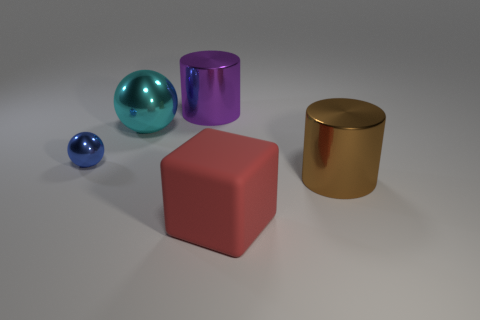Is there a big purple object that is right of the cylinder right of the big red rubber thing?
Your answer should be compact. No. Are there fewer large shiny objects left of the big rubber cube than big brown metallic things?
Keep it short and to the point. No. Is the large thing that is in front of the brown cylinder made of the same material as the brown cylinder?
Your answer should be compact. No. There is a large ball that is the same material as the big brown cylinder; what is its color?
Your response must be concise. Cyan. Is the number of tiny balls that are in front of the rubber cube less than the number of large brown cylinders that are behind the large cyan metal object?
Provide a short and direct response. No. There is a thing right of the large red rubber cube; is it the same color as the big cylinder that is left of the red rubber thing?
Give a very brief answer. No. Are there any brown cylinders made of the same material as the large brown thing?
Give a very brief answer. No. There is a metal cylinder left of the metallic object that is in front of the blue metallic ball; how big is it?
Offer a terse response. Large. Are there more blue things than large green rubber cubes?
Keep it short and to the point. Yes. Is the size of the cylinder that is to the right of the purple metal cylinder the same as the big metallic sphere?
Your response must be concise. Yes. 